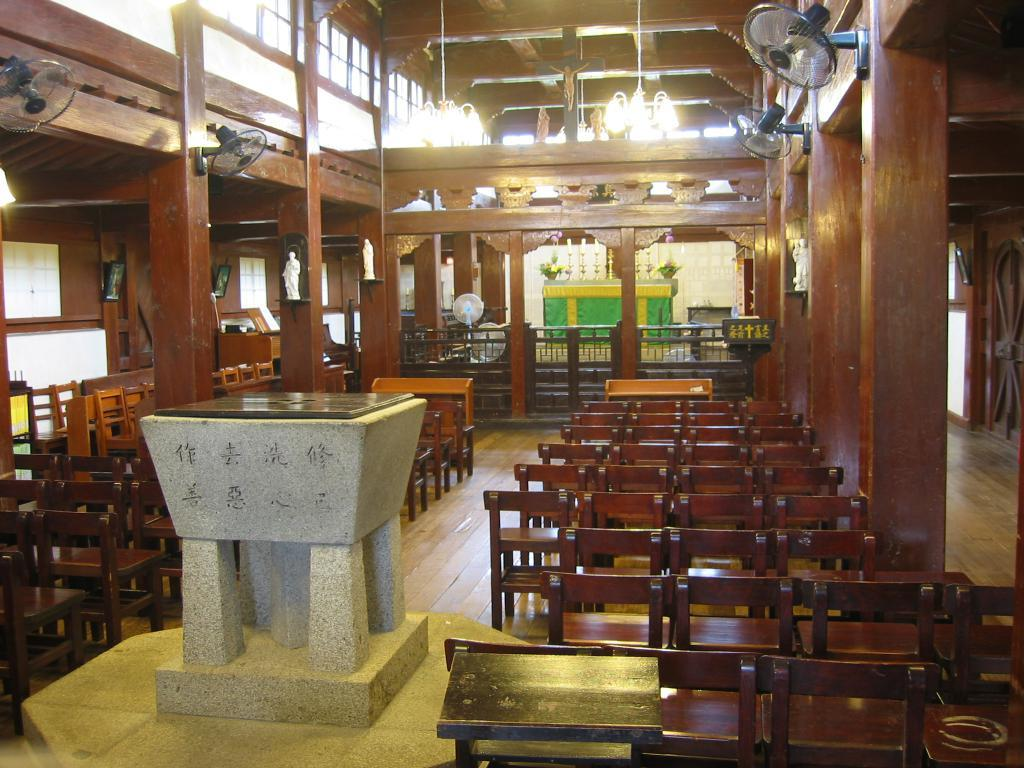What type of furniture is present in the image? There are chairs in the image. What appliances can be seen in the image? There are fans in the image. What sources of illumination are visible in the image? There are lights in the image. What part of the room can be seen in the image? The floor is visible in the image. What type of decorative objects are present in the image? There are small sculptures in the image. What color is the object mentioned in fact 6? There is an object of white color in the image. Can you see any hills in the image? There are no hills present in the image. What type of boundary can be seen in the image? There is no boundary visible in the image. 